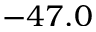<formula> <loc_0><loc_0><loc_500><loc_500>- 4 7 . 0</formula> 